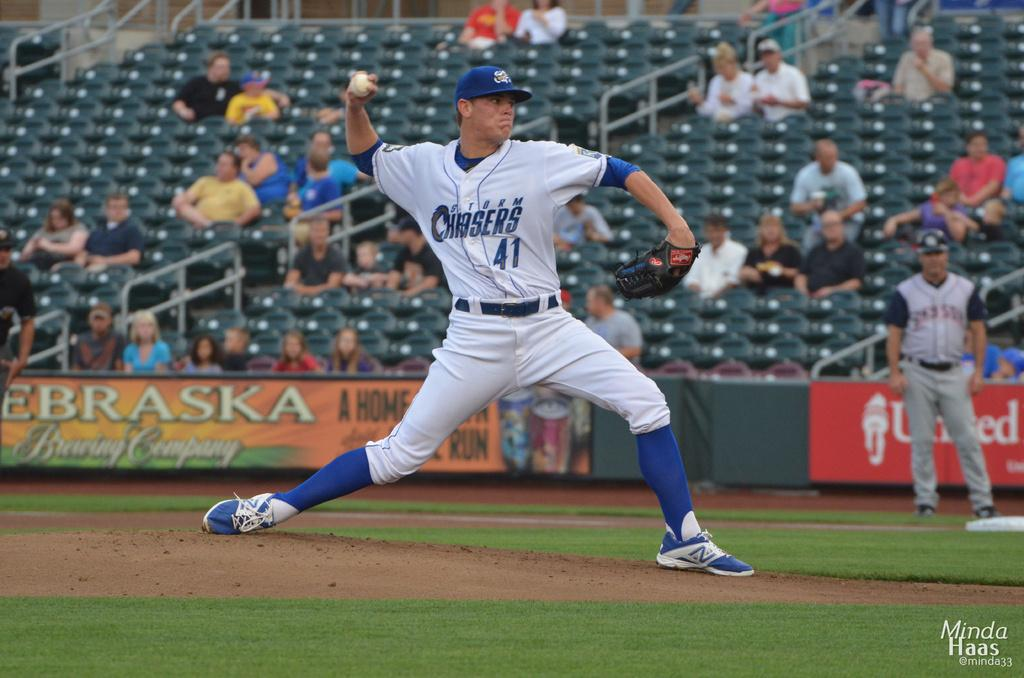<image>
Relay a brief, clear account of the picture shown. Baseball player wearing number 41 pitching the ball. 